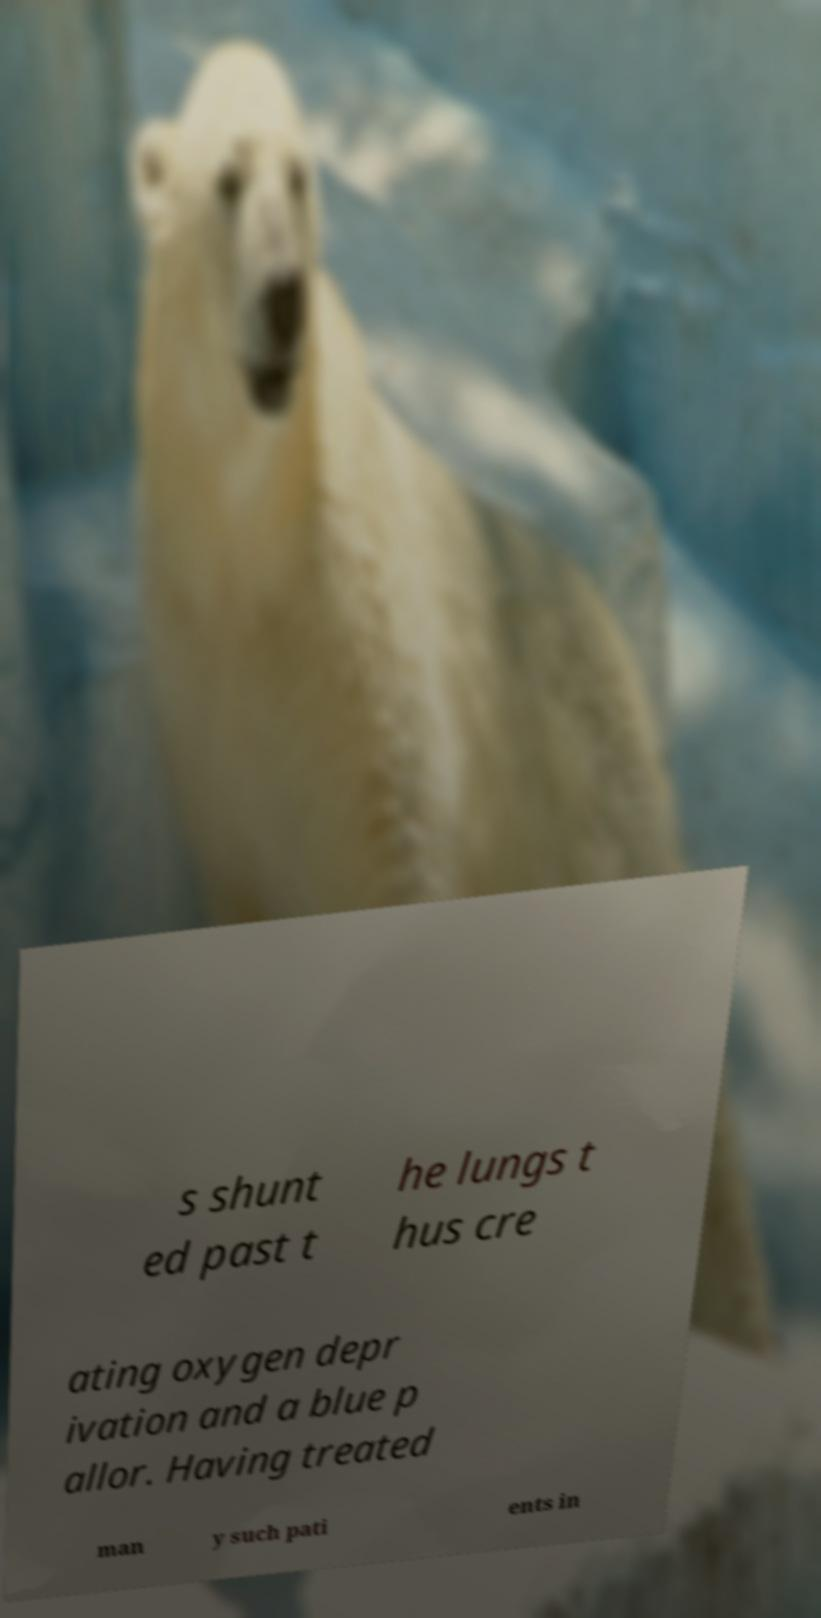There's text embedded in this image that I need extracted. Can you transcribe it verbatim? s shunt ed past t he lungs t hus cre ating oxygen depr ivation and a blue p allor. Having treated man y such pati ents in 